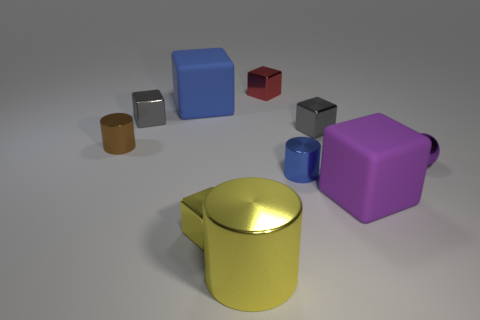Subtract 1 blocks. How many blocks are left? 5 Subtract all gray blocks. How many blocks are left? 4 Subtract all small yellow metallic cubes. How many cubes are left? 5 Subtract all red blocks. Subtract all cyan cylinders. How many blocks are left? 5 Subtract all blocks. How many objects are left? 4 Add 5 big yellow metal cylinders. How many big yellow metal cylinders exist? 6 Subtract 0 yellow balls. How many objects are left? 10 Subtract all tiny purple rubber objects. Subtract all gray things. How many objects are left? 8 Add 2 purple objects. How many purple objects are left? 4 